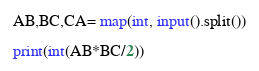<code> <loc_0><loc_0><loc_500><loc_500><_Python_>AB,BC,CA= map(int, input().split())

print(int(AB*BC/2))</code> 